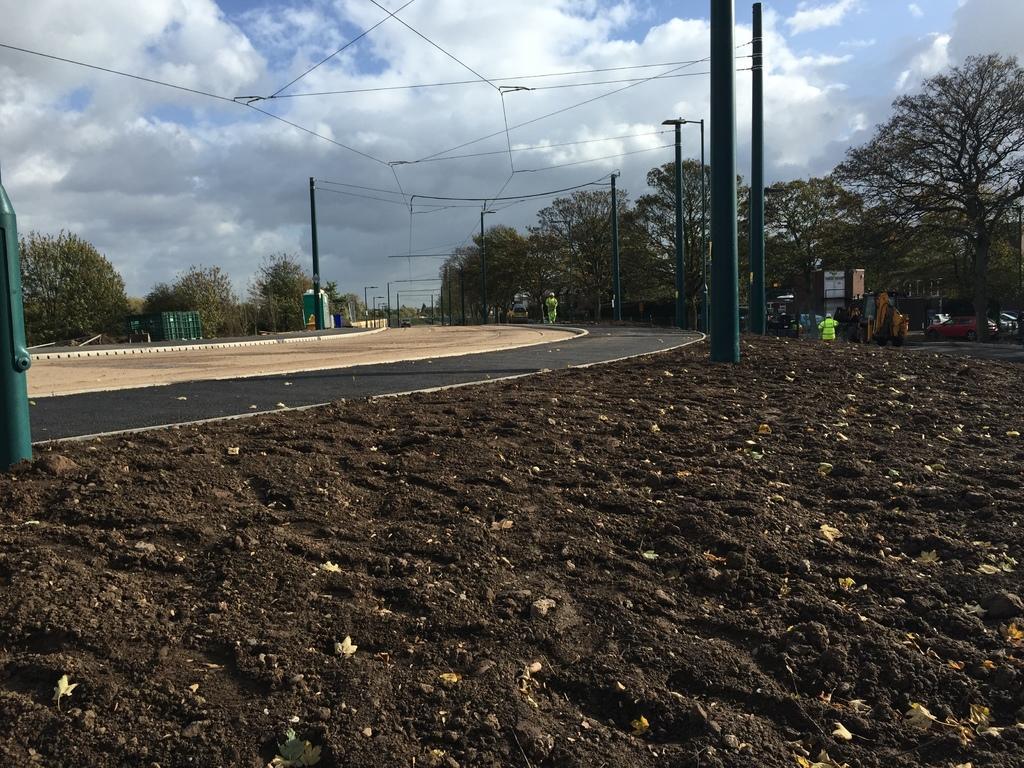Describe this image in one or two sentences. In this image I can see the person walking on the road and I can also see few electric poles, trees, few vehicles and the sky is in blue and white color. 